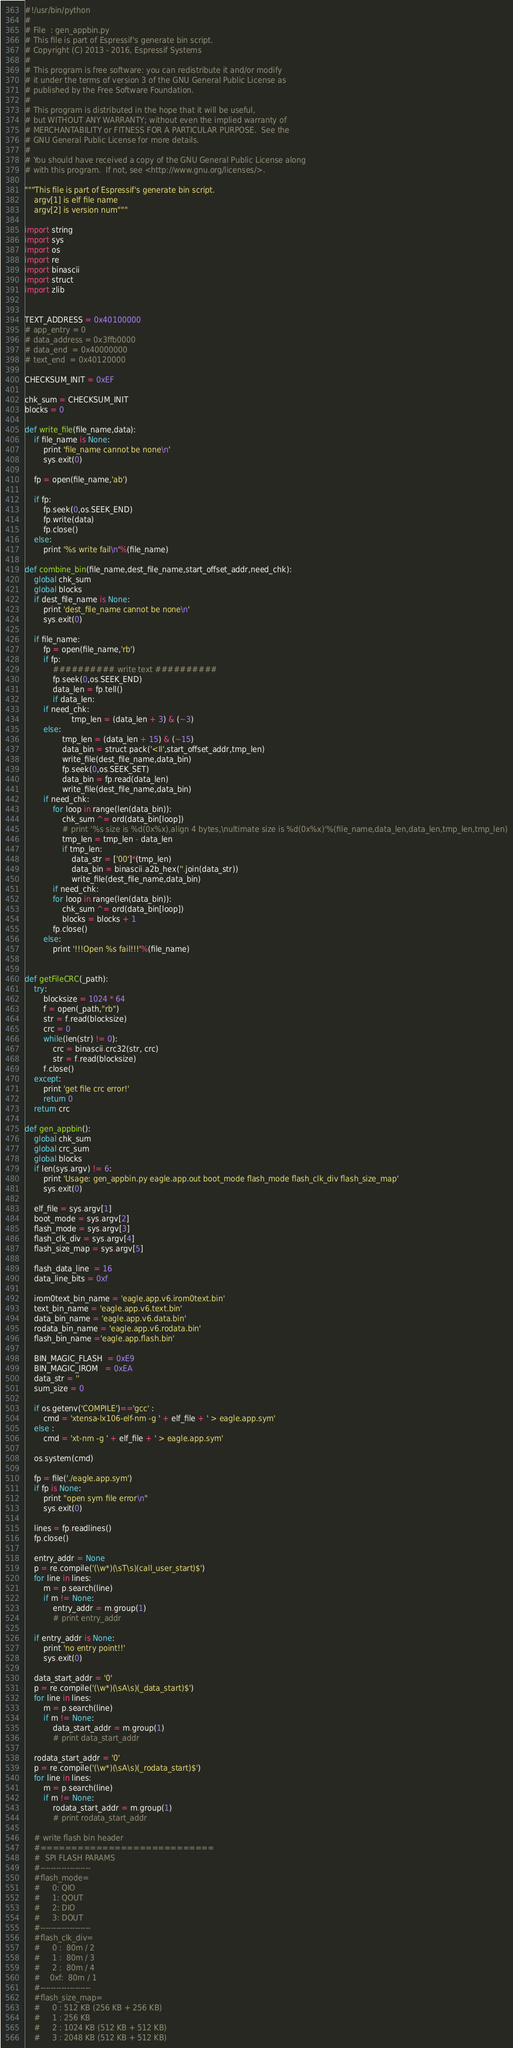<code> <loc_0><loc_0><loc_500><loc_500><_Python_>#!/usr/bin/python
#
# File	: gen_appbin.py
# This file is part of Espressif's generate bin script.
# Copyright (C) 2013 - 2016, Espressif Systems
#
# This program is free software: you can redistribute it and/or modify
# it under the terms of version 3 of the GNU General Public License as
# published by the Free Software Foundation.
#
# This program is distributed in the hope that it will be useful,
# but WITHOUT ANY WARRANTY; without even the implied warranty of
# MERCHANTABILITY or FITNESS FOR A PARTICULAR PURPOSE.  See the
# GNU General Public License for more details.
#
# You should have received a copy of the GNU General Public License along
# with this program.  If not, see <http://www.gnu.org/licenses/>.

"""This file is part of Espressif's generate bin script.
    argv[1] is elf file name
    argv[2] is version num"""

import string
import sys
import os
import re
import binascii
import struct
import zlib


TEXT_ADDRESS = 0x40100000
# app_entry = 0
# data_address = 0x3ffb0000
# data_end  = 0x40000000
# text_end  = 0x40120000

CHECKSUM_INIT = 0xEF

chk_sum = CHECKSUM_INIT
blocks = 0

def write_file(file_name,data):
	if file_name is None:
		print 'file_name cannot be none\n'
		sys.exit(0)

	fp = open(file_name,'ab')

	if fp:
		fp.seek(0,os.SEEK_END)
		fp.write(data)
		fp.close()
	else:
		print '%s write fail\n'%(file_name)

def combine_bin(file_name,dest_file_name,start_offset_addr,need_chk):
    global chk_sum
    global blocks
    if dest_file_name is None:
        print 'dest_file_name cannot be none\n'
        sys.exit(0)

    if file_name:
        fp = open(file_name,'rb')
        if fp:
        	########## write text ##########
            fp.seek(0,os.SEEK_END)
            data_len = fp.tell()
            if data_len:
		if need_chk:
                    tmp_len = (data_len + 3) & (~3)
		else:
	            tmp_len = (data_len + 15) & (~15)
                data_bin = struct.pack('<II',start_offset_addr,tmp_len)
                write_file(dest_file_name,data_bin)
                fp.seek(0,os.SEEK_SET)
                data_bin = fp.read(data_len)
                write_file(dest_file_name,data_bin)
		if need_chk:
		    for loop in range(len(data_bin)):
		        chk_sum ^= ord(data_bin[loop])
                # print '%s size is %d(0x%x),align 4 bytes,\nultimate size is %d(0x%x)'%(file_name,data_len,data_len,tmp_len,tmp_len)
                tmp_len = tmp_len - data_len
                if tmp_len:
                    data_str = ['00']*(tmp_len)
                    data_bin = binascii.a2b_hex(''.join(data_str))
                    write_file(dest_file_name,data_bin)
		    if need_chk:
			for loop in range(len(data_bin)):
			    chk_sum ^= ord(data_bin[loop])
                blocks = blocks + 1
        	fp.close()
        else:
        	print '!!!Open %s fail!!!'%(file_name)


def getFileCRC(_path): 
    try: 
        blocksize = 1024 * 64 
        f = open(_path,"rb") 
        str = f.read(blocksize) 
        crc = 0 
        while(len(str) != 0): 
            crc = binascii.crc32(str, crc) 
            str = f.read(blocksize) 
        f.close() 
    except: 
        print 'get file crc error!' 
        return 0 
    return crc

def gen_appbin():
    global chk_sum
    global crc_sum
    global blocks
    if len(sys.argv) != 6:
        print 'Usage: gen_appbin.py eagle.app.out boot_mode flash_mode flash_clk_div flash_size_map'
        sys.exit(0)

    elf_file = sys.argv[1]
    boot_mode = sys.argv[2]
    flash_mode = sys.argv[3]
    flash_clk_div = sys.argv[4]
    flash_size_map = sys.argv[5]

    flash_data_line  = 16
    data_line_bits = 0xf

    irom0text_bin_name = 'eagle.app.v6.irom0text.bin'
    text_bin_name = 'eagle.app.v6.text.bin'
    data_bin_name = 'eagle.app.v6.data.bin'
    rodata_bin_name = 'eagle.app.v6.rodata.bin'
    flash_bin_name ='eagle.app.flash.bin'

    BIN_MAGIC_FLASH  = 0xE9
    BIN_MAGIC_IROM   = 0xEA
    data_str = ''
    sum_size = 0

    if os.getenv('COMPILE')=='gcc' :
        cmd = 'xtensa-lx106-elf-nm -g ' + elf_file + ' > eagle.app.sym'
    else :
        cmd = 'xt-nm -g ' + elf_file + ' > eagle.app.sym'

    os.system(cmd)

    fp = file('./eagle.app.sym')
    if fp is None:
        print "open sym file error\n"
        sys.exit(0)

    lines = fp.readlines()
    fp.close()

    entry_addr = None
    p = re.compile('(\w*)(\sT\s)(call_user_start)$')
    for line in lines:
        m = p.search(line)
        if m != None:
            entry_addr = m.group(1)
            # print entry_addr

    if entry_addr is None:
        print 'no entry point!!'
        sys.exit(0)

    data_start_addr = '0'
    p = re.compile('(\w*)(\sA\s)(_data_start)$')
    for line in lines:
        m = p.search(line)
        if m != None:
            data_start_addr = m.group(1)
            # print data_start_addr

    rodata_start_addr = '0'
    p = re.compile('(\w*)(\sA\s)(_rodata_start)$')
    for line in lines:
        m = p.search(line)
        if m != None:
            rodata_start_addr = m.group(1)
            # print rodata_start_addr

    # write flash bin header
    #============================
    #  SPI FLASH PARAMS
    #-------------------
    #flash_mode=
    #     0: QIO
    #     1: QOUT
    #     2: DIO
    #     3: DOUT
    #-------------------
    #flash_clk_div=
    #     0 :  80m / 2
    #     1 :  80m / 3
    #     2 :  80m / 4
    #    0xf:  80m / 1
    #-------------------
    #flash_size_map=
    #     0 : 512 KB (256 KB + 256 KB)
    #     1 : 256 KB
    #     2 : 1024 KB (512 KB + 512 KB)
    #     3 : 2048 KB (512 KB + 512 KB)</code> 